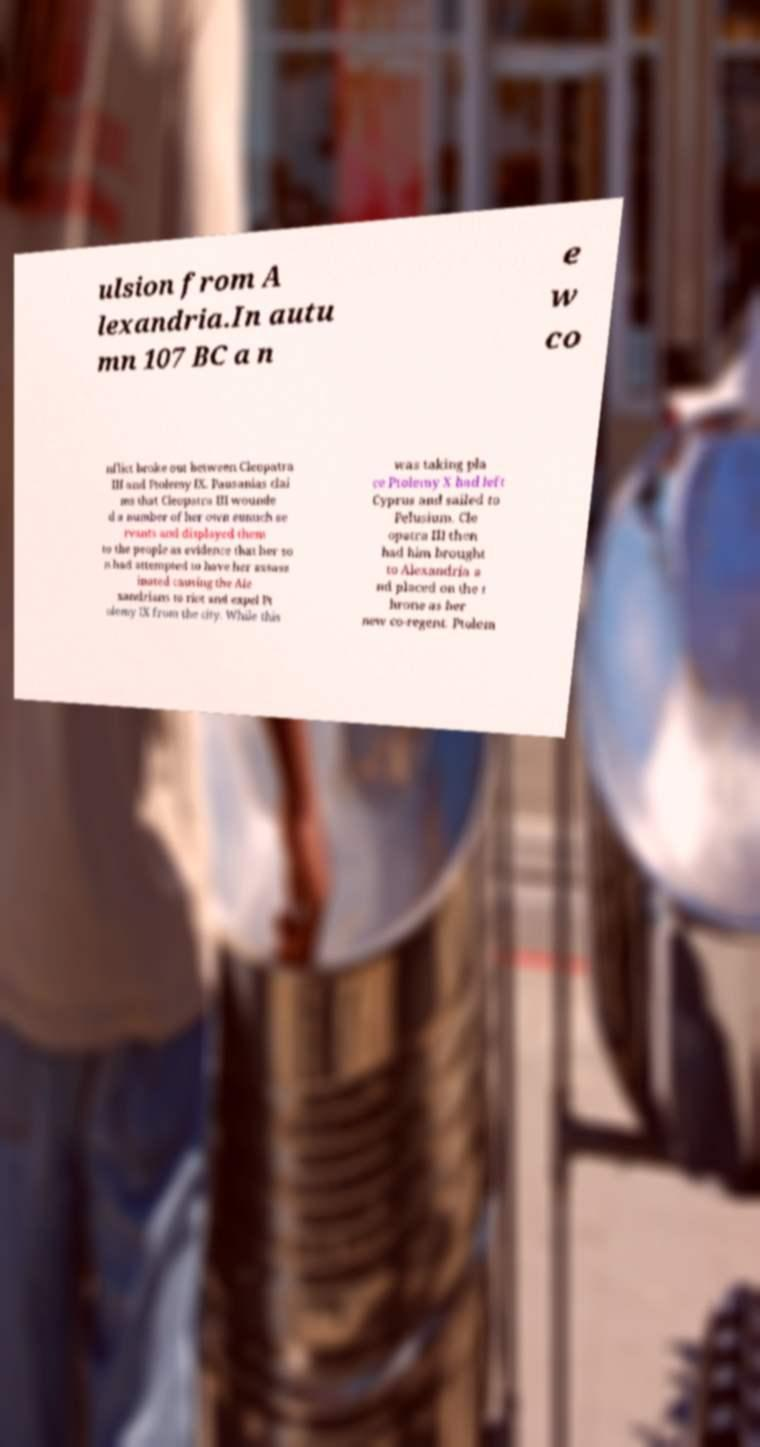Could you assist in decoding the text presented in this image and type it out clearly? ulsion from A lexandria.In autu mn 107 BC a n e w co nflict broke out between Cleopatra III and Ptolemy IX. Pausanias clai ms that Cleopatra III wounde d a number of her own eunuch se rvants and displayed them to the people as evidence that her so n had attempted to have her assass inated causing the Ale xandrians to riot and expel Pt olemy IX from the city. While this was taking pla ce Ptolemy X had left Cyprus and sailed to Pelusium. Cle opatra III then had him brought to Alexandria a nd placed on the t hrone as her new co-regent. Ptolem 